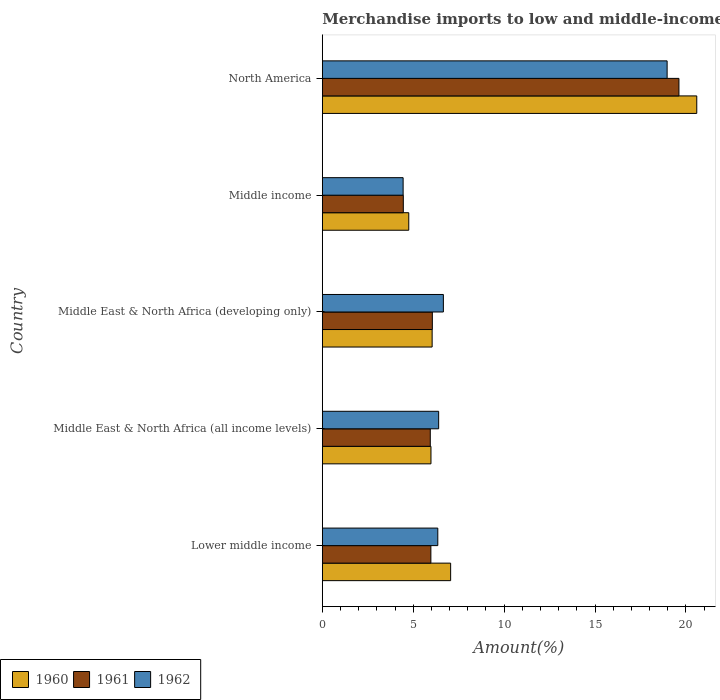Are the number of bars on each tick of the Y-axis equal?
Keep it short and to the point. Yes. What is the label of the 2nd group of bars from the top?
Offer a terse response. Middle income. In how many cases, is the number of bars for a given country not equal to the number of legend labels?
Provide a short and direct response. 0. What is the percentage of amount earned from merchandise imports in 1962 in Middle East & North Africa (developing only)?
Make the answer very short. 6.66. Across all countries, what is the maximum percentage of amount earned from merchandise imports in 1960?
Your response must be concise. 20.6. Across all countries, what is the minimum percentage of amount earned from merchandise imports in 1961?
Make the answer very short. 4.45. In which country was the percentage of amount earned from merchandise imports in 1961 maximum?
Provide a succinct answer. North America. In which country was the percentage of amount earned from merchandise imports in 1962 minimum?
Your response must be concise. Middle income. What is the total percentage of amount earned from merchandise imports in 1960 in the graph?
Your response must be concise. 44.43. What is the difference between the percentage of amount earned from merchandise imports in 1961 in Lower middle income and that in Middle income?
Offer a terse response. 1.52. What is the difference between the percentage of amount earned from merchandise imports in 1961 in North America and the percentage of amount earned from merchandise imports in 1960 in Middle East & North Africa (developing only)?
Make the answer very short. 13.58. What is the average percentage of amount earned from merchandise imports in 1960 per country?
Provide a succinct answer. 8.89. What is the difference between the percentage of amount earned from merchandise imports in 1961 and percentage of amount earned from merchandise imports in 1962 in Middle East & North Africa (developing only)?
Provide a succinct answer. -0.61. In how many countries, is the percentage of amount earned from merchandise imports in 1962 greater than 5 %?
Provide a succinct answer. 4. What is the ratio of the percentage of amount earned from merchandise imports in 1961 in Lower middle income to that in Middle income?
Ensure brevity in your answer.  1.34. What is the difference between the highest and the second highest percentage of amount earned from merchandise imports in 1960?
Your answer should be compact. 13.54. What is the difference between the highest and the lowest percentage of amount earned from merchandise imports in 1961?
Ensure brevity in your answer.  15.16. In how many countries, is the percentage of amount earned from merchandise imports in 1962 greater than the average percentage of amount earned from merchandise imports in 1962 taken over all countries?
Offer a terse response. 1. What does the 2nd bar from the top in Middle East & North Africa (developing only) represents?
Keep it short and to the point. 1961. How many bars are there?
Your answer should be compact. 15. How many countries are there in the graph?
Make the answer very short. 5. Does the graph contain grids?
Keep it short and to the point. No. Where does the legend appear in the graph?
Offer a terse response. Bottom left. How many legend labels are there?
Your answer should be compact. 3. How are the legend labels stacked?
Offer a terse response. Horizontal. What is the title of the graph?
Your answer should be very brief. Merchandise imports to low and middle-income economies outside region. What is the label or title of the X-axis?
Your answer should be very brief. Amount(%). What is the label or title of the Y-axis?
Offer a terse response. Country. What is the Amount(%) of 1960 in Lower middle income?
Your answer should be compact. 7.06. What is the Amount(%) of 1961 in Lower middle income?
Provide a short and direct response. 5.97. What is the Amount(%) in 1962 in Lower middle income?
Your answer should be very brief. 6.35. What is the Amount(%) in 1960 in Middle East & North Africa (all income levels)?
Provide a short and direct response. 5.98. What is the Amount(%) of 1961 in Middle East & North Africa (all income levels)?
Provide a succinct answer. 5.94. What is the Amount(%) of 1962 in Middle East & North Africa (all income levels)?
Make the answer very short. 6.4. What is the Amount(%) in 1960 in Middle East & North Africa (developing only)?
Provide a short and direct response. 6.04. What is the Amount(%) of 1961 in Middle East & North Africa (developing only)?
Make the answer very short. 6.05. What is the Amount(%) in 1962 in Middle East & North Africa (developing only)?
Give a very brief answer. 6.66. What is the Amount(%) of 1960 in Middle income?
Offer a very short reply. 4.75. What is the Amount(%) in 1961 in Middle income?
Your answer should be very brief. 4.45. What is the Amount(%) in 1962 in Middle income?
Give a very brief answer. 4.44. What is the Amount(%) of 1960 in North America?
Keep it short and to the point. 20.6. What is the Amount(%) of 1961 in North America?
Your answer should be very brief. 19.62. What is the Amount(%) in 1962 in North America?
Your answer should be very brief. 18.97. Across all countries, what is the maximum Amount(%) in 1960?
Offer a very short reply. 20.6. Across all countries, what is the maximum Amount(%) of 1961?
Offer a terse response. 19.62. Across all countries, what is the maximum Amount(%) of 1962?
Provide a succinct answer. 18.97. Across all countries, what is the minimum Amount(%) of 1960?
Keep it short and to the point. 4.75. Across all countries, what is the minimum Amount(%) in 1961?
Keep it short and to the point. 4.45. Across all countries, what is the minimum Amount(%) of 1962?
Provide a short and direct response. 4.44. What is the total Amount(%) of 1960 in the graph?
Ensure brevity in your answer.  44.43. What is the total Amount(%) of 1961 in the graph?
Offer a very short reply. 42.03. What is the total Amount(%) of 1962 in the graph?
Offer a very short reply. 42.82. What is the difference between the Amount(%) in 1960 in Lower middle income and that in Middle East & North Africa (all income levels)?
Provide a succinct answer. 1.08. What is the difference between the Amount(%) of 1961 in Lower middle income and that in Middle East & North Africa (all income levels)?
Your response must be concise. 0.03. What is the difference between the Amount(%) in 1962 in Lower middle income and that in Middle East & North Africa (all income levels)?
Your answer should be very brief. -0.05. What is the difference between the Amount(%) of 1960 in Lower middle income and that in Middle East & North Africa (developing only)?
Your answer should be compact. 1.02. What is the difference between the Amount(%) in 1961 in Lower middle income and that in Middle East & North Africa (developing only)?
Your response must be concise. -0.08. What is the difference between the Amount(%) of 1962 in Lower middle income and that in Middle East & North Africa (developing only)?
Keep it short and to the point. -0.31. What is the difference between the Amount(%) in 1960 in Lower middle income and that in Middle income?
Give a very brief answer. 2.3. What is the difference between the Amount(%) in 1961 in Lower middle income and that in Middle income?
Offer a terse response. 1.52. What is the difference between the Amount(%) in 1962 in Lower middle income and that in Middle income?
Give a very brief answer. 1.91. What is the difference between the Amount(%) in 1960 in Lower middle income and that in North America?
Your answer should be very brief. -13.54. What is the difference between the Amount(%) in 1961 in Lower middle income and that in North America?
Keep it short and to the point. -13.64. What is the difference between the Amount(%) in 1962 in Lower middle income and that in North America?
Offer a terse response. -12.61. What is the difference between the Amount(%) in 1960 in Middle East & North Africa (all income levels) and that in Middle East & North Africa (developing only)?
Your answer should be very brief. -0.06. What is the difference between the Amount(%) of 1961 in Middle East & North Africa (all income levels) and that in Middle East & North Africa (developing only)?
Provide a succinct answer. -0.11. What is the difference between the Amount(%) in 1962 in Middle East & North Africa (all income levels) and that in Middle East & North Africa (developing only)?
Your response must be concise. -0.26. What is the difference between the Amount(%) in 1960 in Middle East & North Africa (all income levels) and that in Middle income?
Ensure brevity in your answer.  1.22. What is the difference between the Amount(%) in 1961 in Middle East & North Africa (all income levels) and that in Middle income?
Your answer should be very brief. 1.48. What is the difference between the Amount(%) in 1962 in Middle East & North Africa (all income levels) and that in Middle income?
Ensure brevity in your answer.  1.95. What is the difference between the Amount(%) of 1960 in Middle East & North Africa (all income levels) and that in North America?
Keep it short and to the point. -14.62. What is the difference between the Amount(%) of 1961 in Middle East & North Africa (all income levels) and that in North America?
Your response must be concise. -13.68. What is the difference between the Amount(%) in 1962 in Middle East & North Africa (all income levels) and that in North America?
Make the answer very short. -12.57. What is the difference between the Amount(%) of 1960 in Middle East & North Africa (developing only) and that in Middle income?
Provide a succinct answer. 1.29. What is the difference between the Amount(%) of 1961 in Middle East & North Africa (developing only) and that in Middle income?
Provide a short and direct response. 1.6. What is the difference between the Amount(%) of 1962 in Middle East & North Africa (developing only) and that in Middle income?
Offer a very short reply. 2.21. What is the difference between the Amount(%) of 1960 in Middle East & North Africa (developing only) and that in North America?
Provide a short and direct response. -14.56. What is the difference between the Amount(%) of 1961 in Middle East & North Africa (developing only) and that in North America?
Make the answer very short. -13.56. What is the difference between the Amount(%) in 1962 in Middle East & North Africa (developing only) and that in North America?
Give a very brief answer. -12.31. What is the difference between the Amount(%) of 1960 in Middle income and that in North America?
Make the answer very short. -15.84. What is the difference between the Amount(%) in 1961 in Middle income and that in North America?
Your answer should be very brief. -15.16. What is the difference between the Amount(%) of 1962 in Middle income and that in North America?
Your answer should be compact. -14.52. What is the difference between the Amount(%) in 1960 in Lower middle income and the Amount(%) in 1961 in Middle East & North Africa (all income levels)?
Ensure brevity in your answer.  1.12. What is the difference between the Amount(%) of 1960 in Lower middle income and the Amount(%) of 1962 in Middle East & North Africa (all income levels)?
Provide a short and direct response. 0.66. What is the difference between the Amount(%) in 1961 in Lower middle income and the Amount(%) in 1962 in Middle East & North Africa (all income levels)?
Offer a very short reply. -0.43. What is the difference between the Amount(%) of 1960 in Lower middle income and the Amount(%) of 1961 in Middle East & North Africa (developing only)?
Your answer should be compact. 1.01. What is the difference between the Amount(%) of 1960 in Lower middle income and the Amount(%) of 1962 in Middle East & North Africa (developing only)?
Ensure brevity in your answer.  0.4. What is the difference between the Amount(%) of 1961 in Lower middle income and the Amount(%) of 1962 in Middle East & North Africa (developing only)?
Your answer should be compact. -0.69. What is the difference between the Amount(%) of 1960 in Lower middle income and the Amount(%) of 1961 in Middle income?
Provide a succinct answer. 2.6. What is the difference between the Amount(%) of 1960 in Lower middle income and the Amount(%) of 1962 in Middle income?
Your answer should be compact. 2.61. What is the difference between the Amount(%) in 1961 in Lower middle income and the Amount(%) in 1962 in Middle income?
Ensure brevity in your answer.  1.53. What is the difference between the Amount(%) of 1960 in Lower middle income and the Amount(%) of 1961 in North America?
Offer a terse response. -12.56. What is the difference between the Amount(%) in 1960 in Lower middle income and the Amount(%) in 1962 in North America?
Offer a very short reply. -11.91. What is the difference between the Amount(%) in 1961 in Lower middle income and the Amount(%) in 1962 in North America?
Provide a succinct answer. -12.99. What is the difference between the Amount(%) in 1960 in Middle East & North Africa (all income levels) and the Amount(%) in 1961 in Middle East & North Africa (developing only)?
Keep it short and to the point. -0.08. What is the difference between the Amount(%) in 1960 in Middle East & North Africa (all income levels) and the Amount(%) in 1962 in Middle East & North Africa (developing only)?
Provide a short and direct response. -0.68. What is the difference between the Amount(%) of 1961 in Middle East & North Africa (all income levels) and the Amount(%) of 1962 in Middle East & North Africa (developing only)?
Give a very brief answer. -0.72. What is the difference between the Amount(%) of 1960 in Middle East & North Africa (all income levels) and the Amount(%) of 1961 in Middle income?
Make the answer very short. 1.52. What is the difference between the Amount(%) of 1960 in Middle East & North Africa (all income levels) and the Amount(%) of 1962 in Middle income?
Your answer should be compact. 1.53. What is the difference between the Amount(%) of 1961 in Middle East & North Africa (all income levels) and the Amount(%) of 1962 in Middle income?
Provide a short and direct response. 1.49. What is the difference between the Amount(%) of 1960 in Middle East & North Africa (all income levels) and the Amount(%) of 1961 in North America?
Provide a succinct answer. -13.64. What is the difference between the Amount(%) of 1960 in Middle East & North Africa (all income levels) and the Amount(%) of 1962 in North America?
Offer a terse response. -12.99. What is the difference between the Amount(%) of 1961 in Middle East & North Africa (all income levels) and the Amount(%) of 1962 in North America?
Provide a succinct answer. -13.03. What is the difference between the Amount(%) in 1960 in Middle East & North Africa (developing only) and the Amount(%) in 1961 in Middle income?
Make the answer very short. 1.59. What is the difference between the Amount(%) in 1960 in Middle East & North Africa (developing only) and the Amount(%) in 1962 in Middle income?
Your answer should be very brief. 1.6. What is the difference between the Amount(%) of 1961 in Middle East & North Africa (developing only) and the Amount(%) of 1962 in Middle income?
Make the answer very short. 1.61. What is the difference between the Amount(%) in 1960 in Middle East & North Africa (developing only) and the Amount(%) in 1961 in North America?
Your answer should be very brief. -13.58. What is the difference between the Amount(%) of 1960 in Middle East & North Africa (developing only) and the Amount(%) of 1962 in North America?
Your answer should be very brief. -12.93. What is the difference between the Amount(%) in 1961 in Middle East & North Africa (developing only) and the Amount(%) in 1962 in North America?
Provide a short and direct response. -12.91. What is the difference between the Amount(%) of 1960 in Middle income and the Amount(%) of 1961 in North America?
Your response must be concise. -14.86. What is the difference between the Amount(%) in 1960 in Middle income and the Amount(%) in 1962 in North America?
Keep it short and to the point. -14.21. What is the difference between the Amount(%) in 1961 in Middle income and the Amount(%) in 1962 in North America?
Provide a succinct answer. -14.51. What is the average Amount(%) in 1960 per country?
Ensure brevity in your answer.  8.89. What is the average Amount(%) of 1961 per country?
Provide a succinct answer. 8.41. What is the average Amount(%) of 1962 per country?
Your answer should be very brief. 8.56. What is the difference between the Amount(%) of 1960 and Amount(%) of 1961 in Lower middle income?
Offer a very short reply. 1.09. What is the difference between the Amount(%) of 1960 and Amount(%) of 1962 in Lower middle income?
Your answer should be compact. 0.71. What is the difference between the Amount(%) in 1961 and Amount(%) in 1962 in Lower middle income?
Your answer should be compact. -0.38. What is the difference between the Amount(%) of 1960 and Amount(%) of 1961 in Middle East & North Africa (all income levels)?
Provide a short and direct response. 0.04. What is the difference between the Amount(%) in 1960 and Amount(%) in 1962 in Middle East & North Africa (all income levels)?
Your answer should be very brief. -0.42. What is the difference between the Amount(%) in 1961 and Amount(%) in 1962 in Middle East & North Africa (all income levels)?
Ensure brevity in your answer.  -0.46. What is the difference between the Amount(%) in 1960 and Amount(%) in 1961 in Middle East & North Africa (developing only)?
Your response must be concise. -0.01. What is the difference between the Amount(%) of 1960 and Amount(%) of 1962 in Middle East & North Africa (developing only)?
Your response must be concise. -0.62. What is the difference between the Amount(%) of 1961 and Amount(%) of 1962 in Middle East & North Africa (developing only)?
Provide a succinct answer. -0.61. What is the difference between the Amount(%) of 1960 and Amount(%) of 1961 in Middle income?
Your answer should be very brief. 0.3. What is the difference between the Amount(%) in 1960 and Amount(%) in 1962 in Middle income?
Your answer should be compact. 0.31. What is the difference between the Amount(%) of 1961 and Amount(%) of 1962 in Middle income?
Give a very brief answer. 0.01. What is the difference between the Amount(%) of 1960 and Amount(%) of 1961 in North America?
Give a very brief answer. 0.98. What is the difference between the Amount(%) in 1960 and Amount(%) in 1962 in North America?
Offer a terse response. 1.63. What is the difference between the Amount(%) of 1961 and Amount(%) of 1962 in North America?
Your answer should be very brief. 0.65. What is the ratio of the Amount(%) in 1960 in Lower middle income to that in Middle East & North Africa (all income levels)?
Your response must be concise. 1.18. What is the ratio of the Amount(%) in 1961 in Lower middle income to that in Middle East & North Africa (all income levels)?
Make the answer very short. 1.01. What is the ratio of the Amount(%) in 1960 in Lower middle income to that in Middle East & North Africa (developing only)?
Provide a short and direct response. 1.17. What is the ratio of the Amount(%) of 1961 in Lower middle income to that in Middle East & North Africa (developing only)?
Your response must be concise. 0.99. What is the ratio of the Amount(%) in 1962 in Lower middle income to that in Middle East & North Africa (developing only)?
Provide a short and direct response. 0.95. What is the ratio of the Amount(%) of 1960 in Lower middle income to that in Middle income?
Provide a short and direct response. 1.48. What is the ratio of the Amount(%) of 1961 in Lower middle income to that in Middle income?
Keep it short and to the point. 1.34. What is the ratio of the Amount(%) of 1962 in Lower middle income to that in Middle income?
Your answer should be very brief. 1.43. What is the ratio of the Amount(%) of 1960 in Lower middle income to that in North America?
Give a very brief answer. 0.34. What is the ratio of the Amount(%) in 1961 in Lower middle income to that in North America?
Provide a short and direct response. 0.3. What is the ratio of the Amount(%) of 1962 in Lower middle income to that in North America?
Your answer should be compact. 0.33. What is the ratio of the Amount(%) in 1960 in Middle East & North Africa (all income levels) to that in Middle East & North Africa (developing only)?
Provide a succinct answer. 0.99. What is the ratio of the Amount(%) of 1961 in Middle East & North Africa (all income levels) to that in Middle East & North Africa (developing only)?
Your response must be concise. 0.98. What is the ratio of the Amount(%) in 1962 in Middle East & North Africa (all income levels) to that in Middle East & North Africa (developing only)?
Make the answer very short. 0.96. What is the ratio of the Amount(%) in 1960 in Middle East & North Africa (all income levels) to that in Middle income?
Offer a very short reply. 1.26. What is the ratio of the Amount(%) of 1961 in Middle East & North Africa (all income levels) to that in Middle income?
Your response must be concise. 1.33. What is the ratio of the Amount(%) in 1962 in Middle East & North Africa (all income levels) to that in Middle income?
Make the answer very short. 1.44. What is the ratio of the Amount(%) in 1960 in Middle East & North Africa (all income levels) to that in North America?
Your answer should be very brief. 0.29. What is the ratio of the Amount(%) of 1961 in Middle East & North Africa (all income levels) to that in North America?
Make the answer very short. 0.3. What is the ratio of the Amount(%) of 1962 in Middle East & North Africa (all income levels) to that in North America?
Offer a very short reply. 0.34. What is the ratio of the Amount(%) of 1960 in Middle East & North Africa (developing only) to that in Middle income?
Give a very brief answer. 1.27. What is the ratio of the Amount(%) of 1961 in Middle East & North Africa (developing only) to that in Middle income?
Ensure brevity in your answer.  1.36. What is the ratio of the Amount(%) in 1962 in Middle East & North Africa (developing only) to that in Middle income?
Your answer should be very brief. 1.5. What is the ratio of the Amount(%) of 1960 in Middle East & North Africa (developing only) to that in North America?
Give a very brief answer. 0.29. What is the ratio of the Amount(%) in 1961 in Middle East & North Africa (developing only) to that in North America?
Offer a terse response. 0.31. What is the ratio of the Amount(%) in 1962 in Middle East & North Africa (developing only) to that in North America?
Ensure brevity in your answer.  0.35. What is the ratio of the Amount(%) in 1960 in Middle income to that in North America?
Provide a succinct answer. 0.23. What is the ratio of the Amount(%) of 1961 in Middle income to that in North America?
Provide a short and direct response. 0.23. What is the ratio of the Amount(%) of 1962 in Middle income to that in North America?
Make the answer very short. 0.23. What is the difference between the highest and the second highest Amount(%) in 1960?
Keep it short and to the point. 13.54. What is the difference between the highest and the second highest Amount(%) of 1961?
Your answer should be compact. 13.56. What is the difference between the highest and the second highest Amount(%) in 1962?
Your response must be concise. 12.31. What is the difference between the highest and the lowest Amount(%) of 1960?
Make the answer very short. 15.84. What is the difference between the highest and the lowest Amount(%) of 1961?
Make the answer very short. 15.16. What is the difference between the highest and the lowest Amount(%) of 1962?
Offer a terse response. 14.52. 